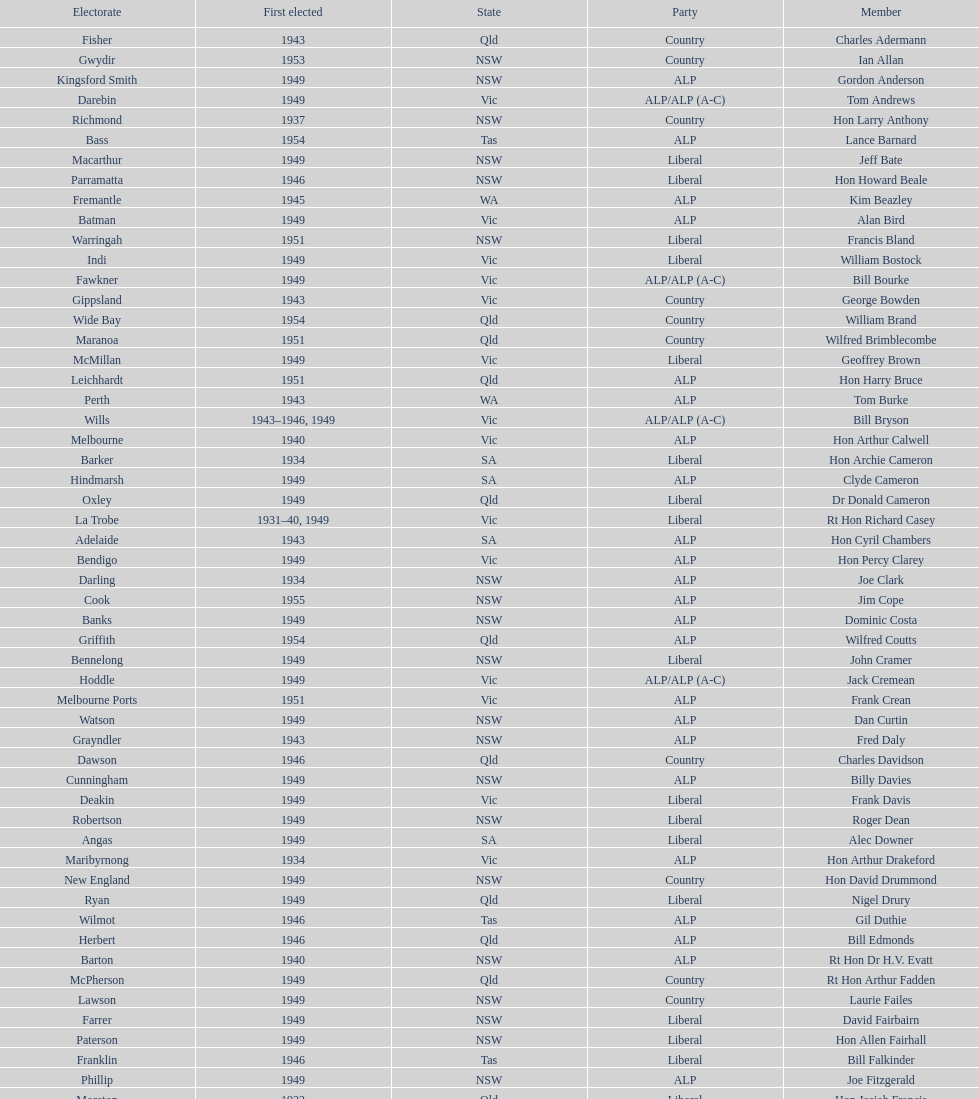After tom burke was elected, what was the next year where another tom would be elected? 1937. 